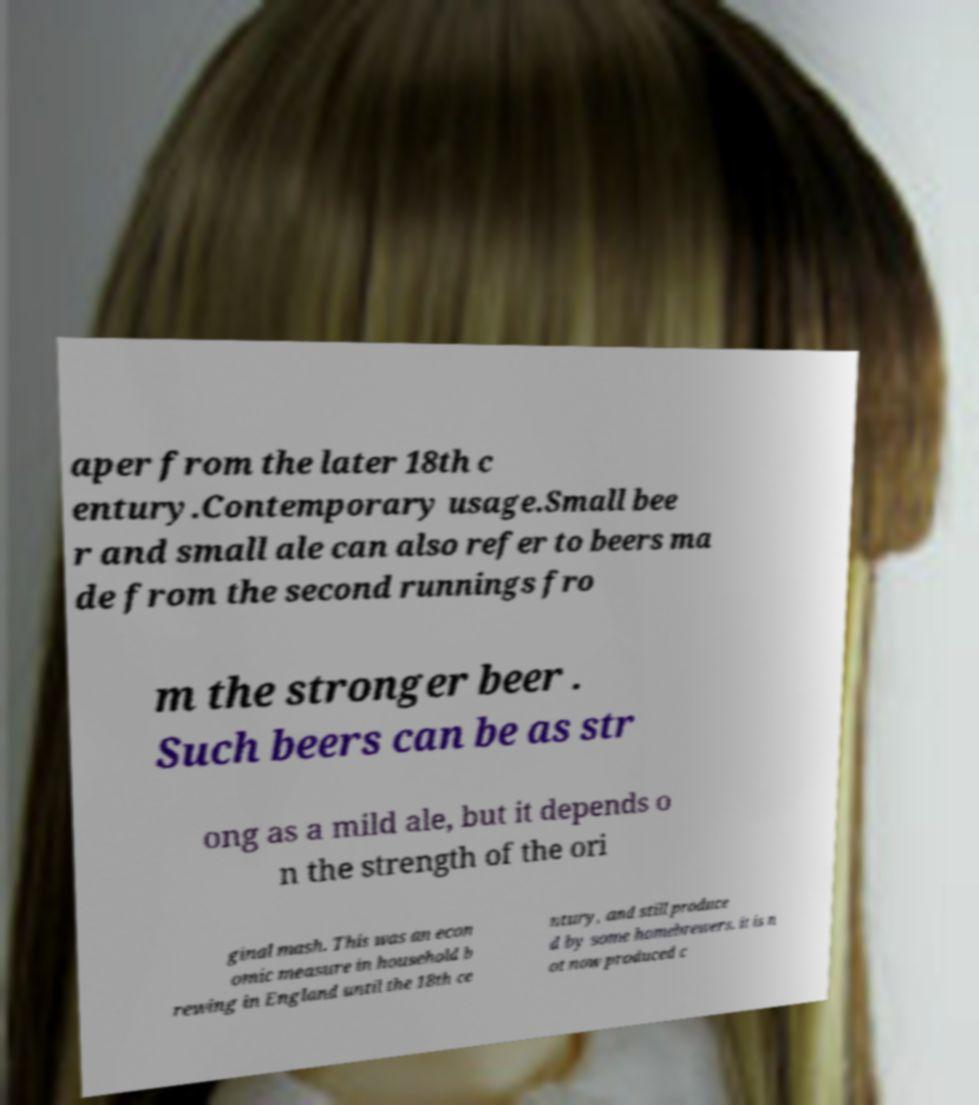I need the written content from this picture converted into text. Can you do that? aper from the later 18th c entury.Contemporary usage.Small bee r and small ale can also refer to beers ma de from the second runnings fro m the stronger beer . Such beers can be as str ong as a mild ale, but it depends o n the strength of the ori ginal mash. This was an econ omic measure in household b rewing in England until the 18th ce ntury, and still produce d by some homebrewers. it is n ot now produced c 